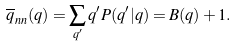<formula> <loc_0><loc_0><loc_500><loc_500>\overline { q } _ { n n } ( q ) = \sum _ { q ^ { \prime } } q ^ { \prime } P ( q ^ { \prime } | q ) = B ( q ) + 1 .</formula> 